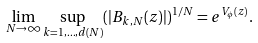Convert formula to latex. <formula><loc_0><loc_0><loc_500><loc_500>\lim _ { N \to \infty } \sup _ { k = 1 , \dots , d ( N ) } ( | B _ { k , N } ( z ) | ) ^ { 1 / N } = e ^ { V _ { \phi } ( z ) } .</formula> 